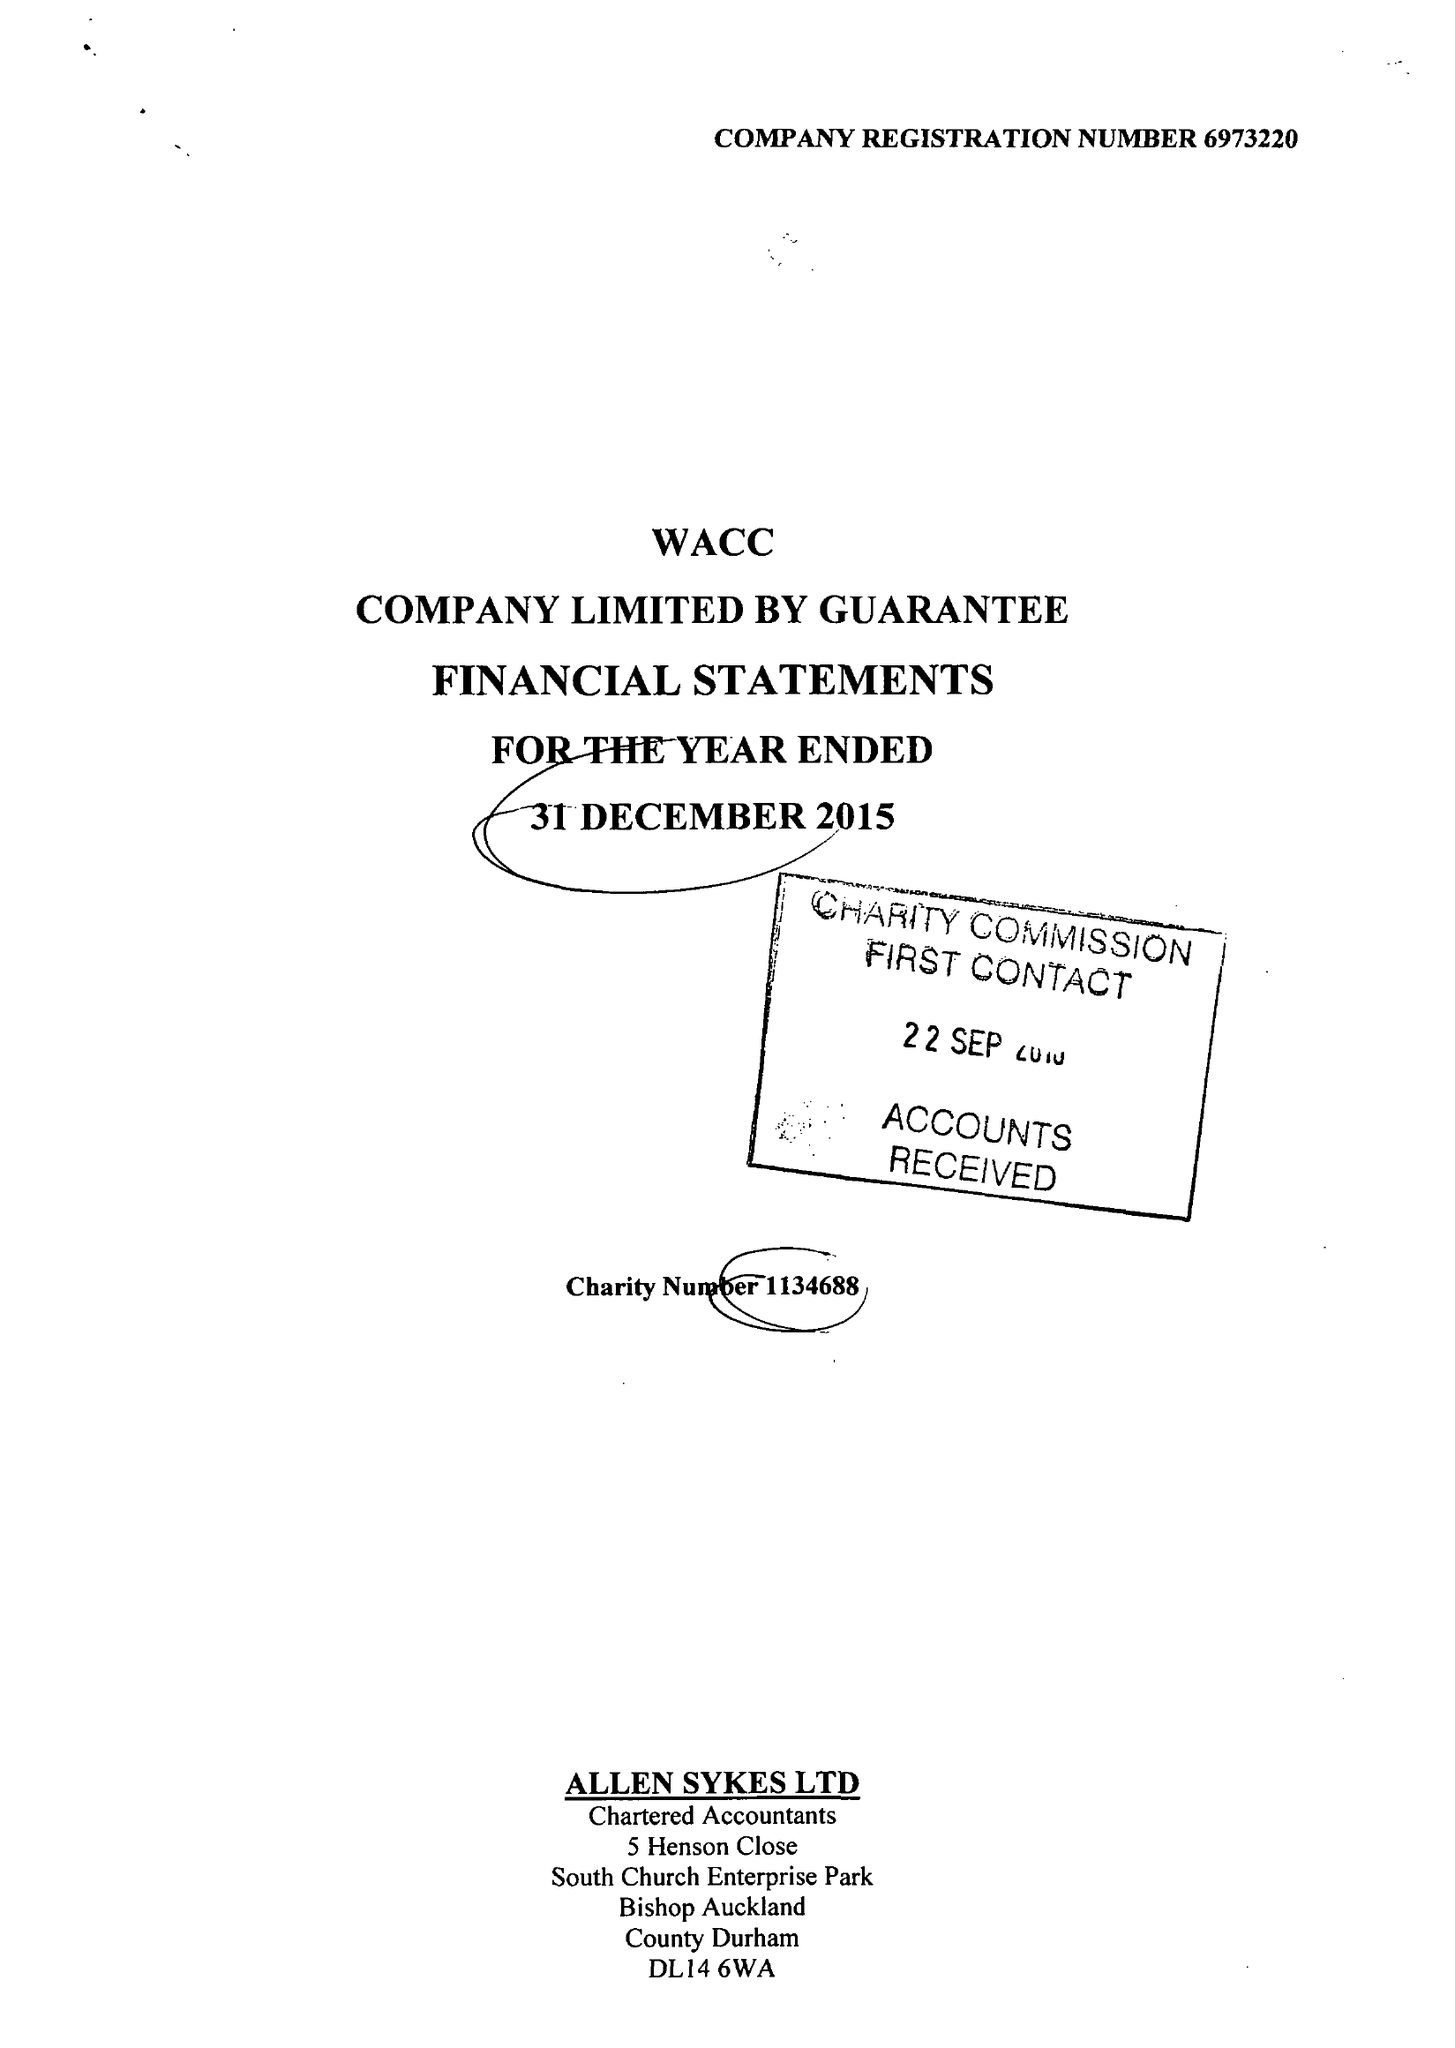What is the value for the report_date?
Answer the question using a single word or phrase. 2015-12-31 